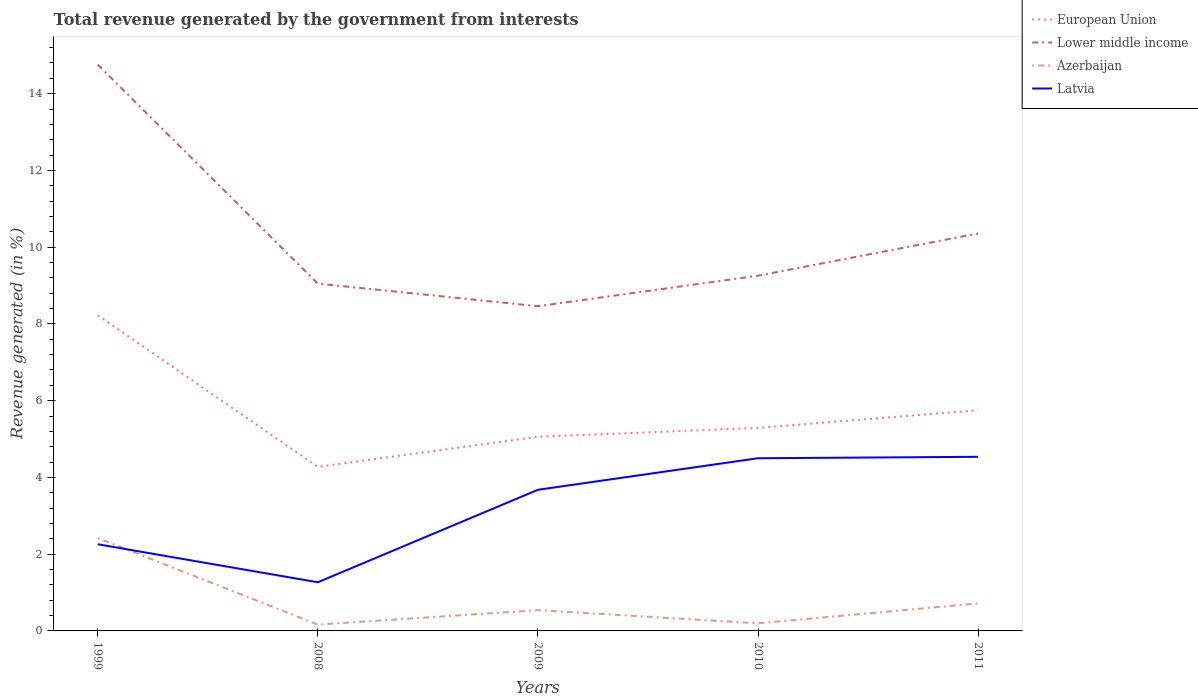How many different coloured lines are there?
Keep it short and to the point. 4. Is the number of lines equal to the number of legend labels?
Provide a short and direct response. Yes. Across all years, what is the maximum total revenue generated in Azerbaijan?
Make the answer very short. 0.17. What is the total total revenue generated in European Union in the graph?
Give a very brief answer. -1.02. What is the difference between the highest and the second highest total revenue generated in Latvia?
Keep it short and to the point. 3.27. Is the total revenue generated in European Union strictly greater than the total revenue generated in Latvia over the years?
Keep it short and to the point. No. How many lines are there?
Your response must be concise. 4. How many years are there in the graph?
Provide a succinct answer. 5. What is the difference between two consecutive major ticks on the Y-axis?
Provide a succinct answer. 2. How many legend labels are there?
Make the answer very short. 4. How are the legend labels stacked?
Give a very brief answer. Vertical. What is the title of the graph?
Provide a succinct answer. Total revenue generated by the government from interests. What is the label or title of the Y-axis?
Provide a short and direct response. Revenue generated (in %). What is the Revenue generated (in %) of European Union in 1999?
Provide a short and direct response. 8.22. What is the Revenue generated (in %) in Lower middle income in 1999?
Give a very brief answer. 14.76. What is the Revenue generated (in %) in Azerbaijan in 1999?
Offer a terse response. 2.42. What is the Revenue generated (in %) of Latvia in 1999?
Offer a terse response. 2.26. What is the Revenue generated (in %) in European Union in 2008?
Offer a terse response. 4.28. What is the Revenue generated (in %) of Lower middle income in 2008?
Your answer should be very brief. 9.05. What is the Revenue generated (in %) in Azerbaijan in 2008?
Offer a terse response. 0.17. What is the Revenue generated (in %) of Latvia in 2008?
Your answer should be very brief. 1.27. What is the Revenue generated (in %) of European Union in 2009?
Provide a short and direct response. 5.06. What is the Revenue generated (in %) of Lower middle income in 2009?
Offer a very short reply. 8.46. What is the Revenue generated (in %) of Azerbaijan in 2009?
Ensure brevity in your answer.  0.54. What is the Revenue generated (in %) of Latvia in 2009?
Offer a very short reply. 3.68. What is the Revenue generated (in %) of European Union in 2010?
Your answer should be compact. 5.29. What is the Revenue generated (in %) in Lower middle income in 2010?
Ensure brevity in your answer.  9.26. What is the Revenue generated (in %) in Azerbaijan in 2010?
Keep it short and to the point. 0.2. What is the Revenue generated (in %) in Latvia in 2010?
Offer a very short reply. 4.5. What is the Revenue generated (in %) of European Union in 2011?
Your response must be concise. 5.75. What is the Revenue generated (in %) of Lower middle income in 2011?
Offer a very short reply. 10.36. What is the Revenue generated (in %) of Azerbaijan in 2011?
Provide a short and direct response. 0.72. What is the Revenue generated (in %) of Latvia in 2011?
Make the answer very short. 4.54. Across all years, what is the maximum Revenue generated (in %) in European Union?
Your response must be concise. 8.22. Across all years, what is the maximum Revenue generated (in %) of Lower middle income?
Your answer should be compact. 14.76. Across all years, what is the maximum Revenue generated (in %) of Azerbaijan?
Offer a terse response. 2.42. Across all years, what is the maximum Revenue generated (in %) in Latvia?
Your response must be concise. 4.54. Across all years, what is the minimum Revenue generated (in %) in European Union?
Your answer should be compact. 4.28. Across all years, what is the minimum Revenue generated (in %) in Lower middle income?
Ensure brevity in your answer.  8.46. Across all years, what is the minimum Revenue generated (in %) of Azerbaijan?
Your response must be concise. 0.17. Across all years, what is the minimum Revenue generated (in %) of Latvia?
Provide a succinct answer. 1.27. What is the total Revenue generated (in %) of European Union in the graph?
Your answer should be compact. 28.6. What is the total Revenue generated (in %) in Lower middle income in the graph?
Make the answer very short. 51.88. What is the total Revenue generated (in %) of Azerbaijan in the graph?
Keep it short and to the point. 4.04. What is the total Revenue generated (in %) of Latvia in the graph?
Offer a terse response. 16.24. What is the difference between the Revenue generated (in %) of European Union in 1999 and that in 2008?
Give a very brief answer. 3.95. What is the difference between the Revenue generated (in %) of Lower middle income in 1999 and that in 2008?
Your answer should be very brief. 5.71. What is the difference between the Revenue generated (in %) of Azerbaijan in 1999 and that in 2008?
Make the answer very short. 2.26. What is the difference between the Revenue generated (in %) in Latvia in 1999 and that in 2008?
Your response must be concise. 0.99. What is the difference between the Revenue generated (in %) of European Union in 1999 and that in 2009?
Make the answer very short. 3.17. What is the difference between the Revenue generated (in %) in Lower middle income in 1999 and that in 2009?
Your answer should be very brief. 6.3. What is the difference between the Revenue generated (in %) in Azerbaijan in 1999 and that in 2009?
Your answer should be compact. 1.88. What is the difference between the Revenue generated (in %) of Latvia in 1999 and that in 2009?
Make the answer very short. -1.42. What is the difference between the Revenue generated (in %) of European Union in 1999 and that in 2010?
Keep it short and to the point. 2.93. What is the difference between the Revenue generated (in %) of Lower middle income in 1999 and that in 2010?
Give a very brief answer. 5.5. What is the difference between the Revenue generated (in %) in Azerbaijan in 1999 and that in 2010?
Offer a very short reply. 2.22. What is the difference between the Revenue generated (in %) in Latvia in 1999 and that in 2010?
Give a very brief answer. -2.24. What is the difference between the Revenue generated (in %) in European Union in 1999 and that in 2011?
Give a very brief answer. 2.47. What is the difference between the Revenue generated (in %) in Lower middle income in 1999 and that in 2011?
Provide a short and direct response. 4.4. What is the difference between the Revenue generated (in %) of Azerbaijan in 1999 and that in 2011?
Make the answer very short. 1.71. What is the difference between the Revenue generated (in %) of Latvia in 1999 and that in 2011?
Keep it short and to the point. -2.28. What is the difference between the Revenue generated (in %) of European Union in 2008 and that in 2009?
Keep it short and to the point. -0.78. What is the difference between the Revenue generated (in %) of Lower middle income in 2008 and that in 2009?
Keep it short and to the point. 0.59. What is the difference between the Revenue generated (in %) of Azerbaijan in 2008 and that in 2009?
Ensure brevity in your answer.  -0.38. What is the difference between the Revenue generated (in %) of Latvia in 2008 and that in 2009?
Keep it short and to the point. -2.41. What is the difference between the Revenue generated (in %) of European Union in 2008 and that in 2010?
Offer a very short reply. -1.01. What is the difference between the Revenue generated (in %) of Lower middle income in 2008 and that in 2010?
Keep it short and to the point. -0.21. What is the difference between the Revenue generated (in %) in Azerbaijan in 2008 and that in 2010?
Ensure brevity in your answer.  -0.03. What is the difference between the Revenue generated (in %) in Latvia in 2008 and that in 2010?
Keep it short and to the point. -3.23. What is the difference between the Revenue generated (in %) of European Union in 2008 and that in 2011?
Your answer should be very brief. -1.48. What is the difference between the Revenue generated (in %) in Lower middle income in 2008 and that in 2011?
Provide a short and direct response. -1.31. What is the difference between the Revenue generated (in %) of Azerbaijan in 2008 and that in 2011?
Give a very brief answer. -0.55. What is the difference between the Revenue generated (in %) in Latvia in 2008 and that in 2011?
Give a very brief answer. -3.27. What is the difference between the Revenue generated (in %) in European Union in 2009 and that in 2010?
Ensure brevity in your answer.  -0.23. What is the difference between the Revenue generated (in %) of Lower middle income in 2009 and that in 2010?
Give a very brief answer. -0.79. What is the difference between the Revenue generated (in %) in Azerbaijan in 2009 and that in 2010?
Make the answer very short. 0.34. What is the difference between the Revenue generated (in %) in Latvia in 2009 and that in 2010?
Offer a very short reply. -0.82. What is the difference between the Revenue generated (in %) in European Union in 2009 and that in 2011?
Make the answer very short. -0.69. What is the difference between the Revenue generated (in %) of Lower middle income in 2009 and that in 2011?
Your answer should be compact. -1.9. What is the difference between the Revenue generated (in %) of Azerbaijan in 2009 and that in 2011?
Give a very brief answer. -0.18. What is the difference between the Revenue generated (in %) of Latvia in 2009 and that in 2011?
Your response must be concise. -0.86. What is the difference between the Revenue generated (in %) in European Union in 2010 and that in 2011?
Offer a terse response. -0.46. What is the difference between the Revenue generated (in %) in Lower middle income in 2010 and that in 2011?
Your answer should be very brief. -1.1. What is the difference between the Revenue generated (in %) of Azerbaijan in 2010 and that in 2011?
Provide a succinct answer. -0.52. What is the difference between the Revenue generated (in %) in Latvia in 2010 and that in 2011?
Offer a terse response. -0.04. What is the difference between the Revenue generated (in %) in European Union in 1999 and the Revenue generated (in %) in Lower middle income in 2008?
Give a very brief answer. -0.83. What is the difference between the Revenue generated (in %) in European Union in 1999 and the Revenue generated (in %) in Azerbaijan in 2008?
Provide a succinct answer. 8.06. What is the difference between the Revenue generated (in %) of European Union in 1999 and the Revenue generated (in %) of Latvia in 2008?
Make the answer very short. 6.96. What is the difference between the Revenue generated (in %) of Lower middle income in 1999 and the Revenue generated (in %) of Azerbaijan in 2008?
Your answer should be very brief. 14.59. What is the difference between the Revenue generated (in %) in Lower middle income in 1999 and the Revenue generated (in %) in Latvia in 2008?
Your answer should be very brief. 13.49. What is the difference between the Revenue generated (in %) of Azerbaijan in 1999 and the Revenue generated (in %) of Latvia in 2008?
Provide a succinct answer. 1.15. What is the difference between the Revenue generated (in %) of European Union in 1999 and the Revenue generated (in %) of Lower middle income in 2009?
Your response must be concise. -0.24. What is the difference between the Revenue generated (in %) of European Union in 1999 and the Revenue generated (in %) of Azerbaijan in 2009?
Ensure brevity in your answer.  7.68. What is the difference between the Revenue generated (in %) in European Union in 1999 and the Revenue generated (in %) in Latvia in 2009?
Give a very brief answer. 4.55. What is the difference between the Revenue generated (in %) of Lower middle income in 1999 and the Revenue generated (in %) of Azerbaijan in 2009?
Your answer should be very brief. 14.22. What is the difference between the Revenue generated (in %) of Lower middle income in 1999 and the Revenue generated (in %) of Latvia in 2009?
Make the answer very short. 11.08. What is the difference between the Revenue generated (in %) in Azerbaijan in 1999 and the Revenue generated (in %) in Latvia in 2009?
Keep it short and to the point. -1.26. What is the difference between the Revenue generated (in %) of European Union in 1999 and the Revenue generated (in %) of Lower middle income in 2010?
Give a very brief answer. -1.03. What is the difference between the Revenue generated (in %) in European Union in 1999 and the Revenue generated (in %) in Azerbaijan in 2010?
Provide a short and direct response. 8.03. What is the difference between the Revenue generated (in %) in European Union in 1999 and the Revenue generated (in %) in Latvia in 2010?
Keep it short and to the point. 3.72. What is the difference between the Revenue generated (in %) of Lower middle income in 1999 and the Revenue generated (in %) of Azerbaijan in 2010?
Keep it short and to the point. 14.56. What is the difference between the Revenue generated (in %) of Lower middle income in 1999 and the Revenue generated (in %) of Latvia in 2010?
Your response must be concise. 10.26. What is the difference between the Revenue generated (in %) of Azerbaijan in 1999 and the Revenue generated (in %) of Latvia in 2010?
Ensure brevity in your answer.  -2.08. What is the difference between the Revenue generated (in %) in European Union in 1999 and the Revenue generated (in %) in Lower middle income in 2011?
Offer a terse response. -2.13. What is the difference between the Revenue generated (in %) of European Union in 1999 and the Revenue generated (in %) of Azerbaijan in 2011?
Ensure brevity in your answer.  7.51. What is the difference between the Revenue generated (in %) of European Union in 1999 and the Revenue generated (in %) of Latvia in 2011?
Make the answer very short. 3.69. What is the difference between the Revenue generated (in %) in Lower middle income in 1999 and the Revenue generated (in %) in Azerbaijan in 2011?
Provide a short and direct response. 14.04. What is the difference between the Revenue generated (in %) in Lower middle income in 1999 and the Revenue generated (in %) in Latvia in 2011?
Offer a very short reply. 10.22. What is the difference between the Revenue generated (in %) of Azerbaijan in 1999 and the Revenue generated (in %) of Latvia in 2011?
Provide a short and direct response. -2.12. What is the difference between the Revenue generated (in %) of European Union in 2008 and the Revenue generated (in %) of Lower middle income in 2009?
Your answer should be compact. -4.19. What is the difference between the Revenue generated (in %) in European Union in 2008 and the Revenue generated (in %) in Azerbaijan in 2009?
Ensure brevity in your answer.  3.73. What is the difference between the Revenue generated (in %) of European Union in 2008 and the Revenue generated (in %) of Latvia in 2009?
Provide a succinct answer. 0.6. What is the difference between the Revenue generated (in %) of Lower middle income in 2008 and the Revenue generated (in %) of Azerbaijan in 2009?
Provide a short and direct response. 8.51. What is the difference between the Revenue generated (in %) of Lower middle income in 2008 and the Revenue generated (in %) of Latvia in 2009?
Provide a short and direct response. 5.37. What is the difference between the Revenue generated (in %) of Azerbaijan in 2008 and the Revenue generated (in %) of Latvia in 2009?
Ensure brevity in your answer.  -3.51. What is the difference between the Revenue generated (in %) in European Union in 2008 and the Revenue generated (in %) in Lower middle income in 2010?
Ensure brevity in your answer.  -4.98. What is the difference between the Revenue generated (in %) of European Union in 2008 and the Revenue generated (in %) of Azerbaijan in 2010?
Your answer should be compact. 4.08. What is the difference between the Revenue generated (in %) of European Union in 2008 and the Revenue generated (in %) of Latvia in 2010?
Keep it short and to the point. -0.23. What is the difference between the Revenue generated (in %) in Lower middle income in 2008 and the Revenue generated (in %) in Azerbaijan in 2010?
Ensure brevity in your answer.  8.85. What is the difference between the Revenue generated (in %) of Lower middle income in 2008 and the Revenue generated (in %) of Latvia in 2010?
Your answer should be very brief. 4.55. What is the difference between the Revenue generated (in %) of Azerbaijan in 2008 and the Revenue generated (in %) of Latvia in 2010?
Provide a short and direct response. -4.33. What is the difference between the Revenue generated (in %) of European Union in 2008 and the Revenue generated (in %) of Lower middle income in 2011?
Your answer should be very brief. -6.08. What is the difference between the Revenue generated (in %) in European Union in 2008 and the Revenue generated (in %) in Azerbaijan in 2011?
Offer a very short reply. 3.56. What is the difference between the Revenue generated (in %) of European Union in 2008 and the Revenue generated (in %) of Latvia in 2011?
Your answer should be compact. -0.26. What is the difference between the Revenue generated (in %) in Lower middle income in 2008 and the Revenue generated (in %) in Azerbaijan in 2011?
Offer a very short reply. 8.33. What is the difference between the Revenue generated (in %) in Lower middle income in 2008 and the Revenue generated (in %) in Latvia in 2011?
Offer a terse response. 4.51. What is the difference between the Revenue generated (in %) in Azerbaijan in 2008 and the Revenue generated (in %) in Latvia in 2011?
Provide a succinct answer. -4.37. What is the difference between the Revenue generated (in %) of European Union in 2009 and the Revenue generated (in %) of Lower middle income in 2010?
Keep it short and to the point. -4.2. What is the difference between the Revenue generated (in %) in European Union in 2009 and the Revenue generated (in %) in Azerbaijan in 2010?
Your answer should be very brief. 4.86. What is the difference between the Revenue generated (in %) of European Union in 2009 and the Revenue generated (in %) of Latvia in 2010?
Your response must be concise. 0.56. What is the difference between the Revenue generated (in %) in Lower middle income in 2009 and the Revenue generated (in %) in Azerbaijan in 2010?
Your response must be concise. 8.26. What is the difference between the Revenue generated (in %) in Lower middle income in 2009 and the Revenue generated (in %) in Latvia in 2010?
Provide a succinct answer. 3.96. What is the difference between the Revenue generated (in %) of Azerbaijan in 2009 and the Revenue generated (in %) of Latvia in 2010?
Offer a terse response. -3.96. What is the difference between the Revenue generated (in %) of European Union in 2009 and the Revenue generated (in %) of Lower middle income in 2011?
Provide a succinct answer. -5.3. What is the difference between the Revenue generated (in %) in European Union in 2009 and the Revenue generated (in %) in Azerbaijan in 2011?
Provide a succinct answer. 4.34. What is the difference between the Revenue generated (in %) in European Union in 2009 and the Revenue generated (in %) in Latvia in 2011?
Ensure brevity in your answer.  0.52. What is the difference between the Revenue generated (in %) of Lower middle income in 2009 and the Revenue generated (in %) of Azerbaijan in 2011?
Ensure brevity in your answer.  7.75. What is the difference between the Revenue generated (in %) in Lower middle income in 2009 and the Revenue generated (in %) in Latvia in 2011?
Give a very brief answer. 3.92. What is the difference between the Revenue generated (in %) in Azerbaijan in 2009 and the Revenue generated (in %) in Latvia in 2011?
Provide a short and direct response. -4. What is the difference between the Revenue generated (in %) of European Union in 2010 and the Revenue generated (in %) of Lower middle income in 2011?
Your answer should be very brief. -5.07. What is the difference between the Revenue generated (in %) in European Union in 2010 and the Revenue generated (in %) in Azerbaijan in 2011?
Give a very brief answer. 4.57. What is the difference between the Revenue generated (in %) in European Union in 2010 and the Revenue generated (in %) in Latvia in 2011?
Offer a terse response. 0.75. What is the difference between the Revenue generated (in %) of Lower middle income in 2010 and the Revenue generated (in %) of Azerbaijan in 2011?
Provide a short and direct response. 8.54. What is the difference between the Revenue generated (in %) in Lower middle income in 2010 and the Revenue generated (in %) in Latvia in 2011?
Make the answer very short. 4.72. What is the difference between the Revenue generated (in %) in Azerbaijan in 2010 and the Revenue generated (in %) in Latvia in 2011?
Make the answer very short. -4.34. What is the average Revenue generated (in %) of European Union per year?
Offer a terse response. 5.72. What is the average Revenue generated (in %) in Lower middle income per year?
Make the answer very short. 10.38. What is the average Revenue generated (in %) of Azerbaijan per year?
Offer a terse response. 0.81. What is the average Revenue generated (in %) in Latvia per year?
Your answer should be very brief. 3.25. In the year 1999, what is the difference between the Revenue generated (in %) in European Union and Revenue generated (in %) in Lower middle income?
Provide a succinct answer. -6.53. In the year 1999, what is the difference between the Revenue generated (in %) in European Union and Revenue generated (in %) in Azerbaijan?
Provide a succinct answer. 5.8. In the year 1999, what is the difference between the Revenue generated (in %) in European Union and Revenue generated (in %) in Latvia?
Your response must be concise. 5.97. In the year 1999, what is the difference between the Revenue generated (in %) of Lower middle income and Revenue generated (in %) of Azerbaijan?
Your answer should be compact. 12.34. In the year 1999, what is the difference between the Revenue generated (in %) in Lower middle income and Revenue generated (in %) in Latvia?
Ensure brevity in your answer.  12.5. In the year 1999, what is the difference between the Revenue generated (in %) of Azerbaijan and Revenue generated (in %) of Latvia?
Provide a short and direct response. 0.16. In the year 2008, what is the difference between the Revenue generated (in %) of European Union and Revenue generated (in %) of Lower middle income?
Keep it short and to the point. -4.78. In the year 2008, what is the difference between the Revenue generated (in %) of European Union and Revenue generated (in %) of Azerbaijan?
Provide a succinct answer. 4.11. In the year 2008, what is the difference between the Revenue generated (in %) of European Union and Revenue generated (in %) of Latvia?
Provide a succinct answer. 3.01. In the year 2008, what is the difference between the Revenue generated (in %) in Lower middle income and Revenue generated (in %) in Azerbaijan?
Offer a terse response. 8.88. In the year 2008, what is the difference between the Revenue generated (in %) in Lower middle income and Revenue generated (in %) in Latvia?
Give a very brief answer. 7.78. In the year 2008, what is the difference between the Revenue generated (in %) in Azerbaijan and Revenue generated (in %) in Latvia?
Your answer should be compact. -1.1. In the year 2009, what is the difference between the Revenue generated (in %) of European Union and Revenue generated (in %) of Lower middle income?
Ensure brevity in your answer.  -3.4. In the year 2009, what is the difference between the Revenue generated (in %) of European Union and Revenue generated (in %) of Azerbaijan?
Provide a succinct answer. 4.52. In the year 2009, what is the difference between the Revenue generated (in %) of European Union and Revenue generated (in %) of Latvia?
Make the answer very short. 1.38. In the year 2009, what is the difference between the Revenue generated (in %) in Lower middle income and Revenue generated (in %) in Azerbaijan?
Offer a very short reply. 7.92. In the year 2009, what is the difference between the Revenue generated (in %) in Lower middle income and Revenue generated (in %) in Latvia?
Keep it short and to the point. 4.78. In the year 2009, what is the difference between the Revenue generated (in %) of Azerbaijan and Revenue generated (in %) of Latvia?
Provide a succinct answer. -3.14. In the year 2010, what is the difference between the Revenue generated (in %) in European Union and Revenue generated (in %) in Lower middle income?
Offer a very short reply. -3.97. In the year 2010, what is the difference between the Revenue generated (in %) in European Union and Revenue generated (in %) in Azerbaijan?
Give a very brief answer. 5.09. In the year 2010, what is the difference between the Revenue generated (in %) of European Union and Revenue generated (in %) of Latvia?
Make the answer very short. 0.79. In the year 2010, what is the difference between the Revenue generated (in %) in Lower middle income and Revenue generated (in %) in Azerbaijan?
Ensure brevity in your answer.  9.06. In the year 2010, what is the difference between the Revenue generated (in %) in Lower middle income and Revenue generated (in %) in Latvia?
Offer a terse response. 4.76. In the year 2010, what is the difference between the Revenue generated (in %) in Azerbaijan and Revenue generated (in %) in Latvia?
Offer a very short reply. -4.3. In the year 2011, what is the difference between the Revenue generated (in %) in European Union and Revenue generated (in %) in Lower middle income?
Ensure brevity in your answer.  -4.61. In the year 2011, what is the difference between the Revenue generated (in %) of European Union and Revenue generated (in %) of Azerbaijan?
Provide a succinct answer. 5.04. In the year 2011, what is the difference between the Revenue generated (in %) of European Union and Revenue generated (in %) of Latvia?
Give a very brief answer. 1.21. In the year 2011, what is the difference between the Revenue generated (in %) in Lower middle income and Revenue generated (in %) in Azerbaijan?
Offer a very short reply. 9.64. In the year 2011, what is the difference between the Revenue generated (in %) in Lower middle income and Revenue generated (in %) in Latvia?
Give a very brief answer. 5.82. In the year 2011, what is the difference between the Revenue generated (in %) in Azerbaijan and Revenue generated (in %) in Latvia?
Keep it short and to the point. -3.82. What is the ratio of the Revenue generated (in %) in European Union in 1999 to that in 2008?
Offer a terse response. 1.92. What is the ratio of the Revenue generated (in %) of Lower middle income in 1999 to that in 2008?
Provide a succinct answer. 1.63. What is the ratio of the Revenue generated (in %) in Azerbaijan in 1999 to that in 2008?
Make the answer very short. 14.65. What is the ratio of the Revenue generated (in %) in Latvia in 1999 to that in 2008?
Your response must be concise. 1.78. What is the ratio of the Revenue generated (in %) of European Union in 1999 to that in 2009?
Give a very brief answer. 1.63. What is the ratio of the Revenue generated (in %) in Lower middle income in 1999 to that in 2009?
Keep it short and to the point. 1.74. What is the ratio of the Revenue generated (in %) of Azerbaijan in 1999 to that in 2009?
Ensure brevity in your answer.  4.48. What is the ratio of the Revenue generated (in %) in Latvia in 1999 to that in 2009?
Make the answer very short. 0.61. What is the ratio of the Revenue generated (in %) of European Union in 1999 to that in 2010?
Ensure brevity in your answer.  1.55. What is the ratio of the Revenue generated (in %) in Lower middle income in 1999 to that in 2010?
Your response must be concise. 1.59. What is the ratio of the Revenue generated (in %) of Azerbaijan in 1999 to that in 2010?
Provide a short and direct response. 12.19. What is the ratio of the Revenue generated (in %) in Latvia in 1999 to that in 2010?
Your answer should be compact. 0.5. What is the ratio of the Revenue generated (in %) of European Union in 1999 to that in 2011?
Give a very brief answer. 1.43. What is the ratio of the Revenue generated (in %) of Lower middle income in 1999 to that in 2011?
Make the answer very short. 1.42. What is the ratio of the Revenue generated (in %) in Azerbaijan in 1999 to that in 2011?
Provide a short and direct response. 3.38. What is the ratio of the Revenue generated (in %) of Latvia in 1999 to that in 2011?
Make the answer very short. 0.5. What is the ratio of the Revenue generated (in %) of European Union in 2008 to that in 2009?
Your answer should be very brief. 0.84. What is the ratio of the Revenue generated (in %) of Lower middle income in 2008 to that in 2009?
Provide a succinct answer. 1.07. What is the ratio of the Revenue generated (in %) of Azerbaijan in 2008 to that in 2009?
Your answer should be compact. 0.31. What is the ratio of the Revenue generated (in %) of Latvia in 2008 to that in 2009?
Ensure brevity in your answer.  0.34. What is the ratio of the Revenue generated (in %) in European Union in 2008 to that in 2010?
Keep it short and to the point. 0.81. What is the ratio of the Revenue generated (in %) in Lower middle income in 2008 to that in 2010?
Offer a very short reply. 0.98. What is the ratio of the Revenue generated (in %) of Azerbaijan in 2008 to that in 2010?
Your response must be concise. 0.83. What is the ratio of the Revenue generated (in %) in Latvia in 2008 to that in 2010?
Your response must be concise. 0.28. What is the ratio of the Revenue generated (in %) in European Union in 2008 to that in 2011?
Provide a short and direct response. 0.74. What is the ratio of the Revenue generated (in %) of Lower middle income in 2008 to that in 2011?
Make the answer very short. 0.87. What is the ratio of the Revenue generated (in %) of Azerbaijan in 2008 to that in 2011?
Keep it short and to the point. 0.23. What is the ratio of the Revenue generated (in %) in Latvia in 2008 to that in 2011?
Your answer should be very brief. 0.28. What is the ratio of the Revenue generated (in %) in European Union in 2009 to that in 2010?
Offer a very short reply. 0.96. What is the ratio of the Revenue generated (in %) in Lower middle income in 2009 to that in 2010?
Your answer should be very brief. 0.91. What is the ratio of the Revenue generated (in %) in Azerbaijan in 2009 to that in 2010?
Your response must be concise. 2.72. What is the ratio of the Revenue generated (in %) in Latvia in 2009 to that in 2010?
Make the answer very short. 0.82. What is the ratio of the Revenue generated (in %) of European Union in 2009 to that in 2011?
Keep it short and to the point. 0.88. What is the ratio of the Revenue generated (in %) in Lower middle income in 2009 to that in 2011?
Give a very brief answer. 0.82. What is the ratio of the Revenue generated (in %) of Azerbaijan in 2009 to that in 2011?
Ensure brevity in your answer.  0.76. What is the ratio of the Revenue generated (in %) of Latvia in 2009 to that in 2011?
Provide a succinct answer. 0.81. What is the ratio of the Revenue generated (in %) of European Union in 2010 to that in 2011?
Offer a very short reply. 0.92. What is the ratio of the Revenue generated (in %) in Lower middle income in 2010 to that in 2011?
Ensure brevity in your answer.  0.89. What is the ratio of the Revenue generated (in %) of Azerbaijan in 2010 to that in 2011?
Provide a short and direct response. 0.28. What is the ratio of the Revenue generated (in %) of Latvia in 2010 to that in 2011?
Your response must be concise. 0.99. What is the difference between the highest and the second highest Revenue generated (in %) in European Union?
Offer a terse response. 2.47. What is the difference between the highest and the second highest Revenue generated (in %) in Lower middle income?
Your response must be concise. 4.4. What is the difference between the highest and the second highest Revenue generated (in %) of Azerbaijan?
Provide a succinct answer. 1.71. What is the difference between the highest and the second highest Revenue generated (in %) in Latvia?
Offer a terse response. 0.04. What is the difference between the highest and the lowest Revenue generated (in %) in European Union?
Make the answer very short. 3.95. What is the difference between the highest and the lowest Revenue generated (in %) in Lower middle income?
Keep it short and to the point. 6.3. What is the difference between the highest and the lowest Revenue generated (in %) of Azerbaijan?
Give a very brief answer. 2.26. What is the difference between the highest and the lowest Revenue generated (in %) in Latvia?
Provide a succinct answer. 3.27. 